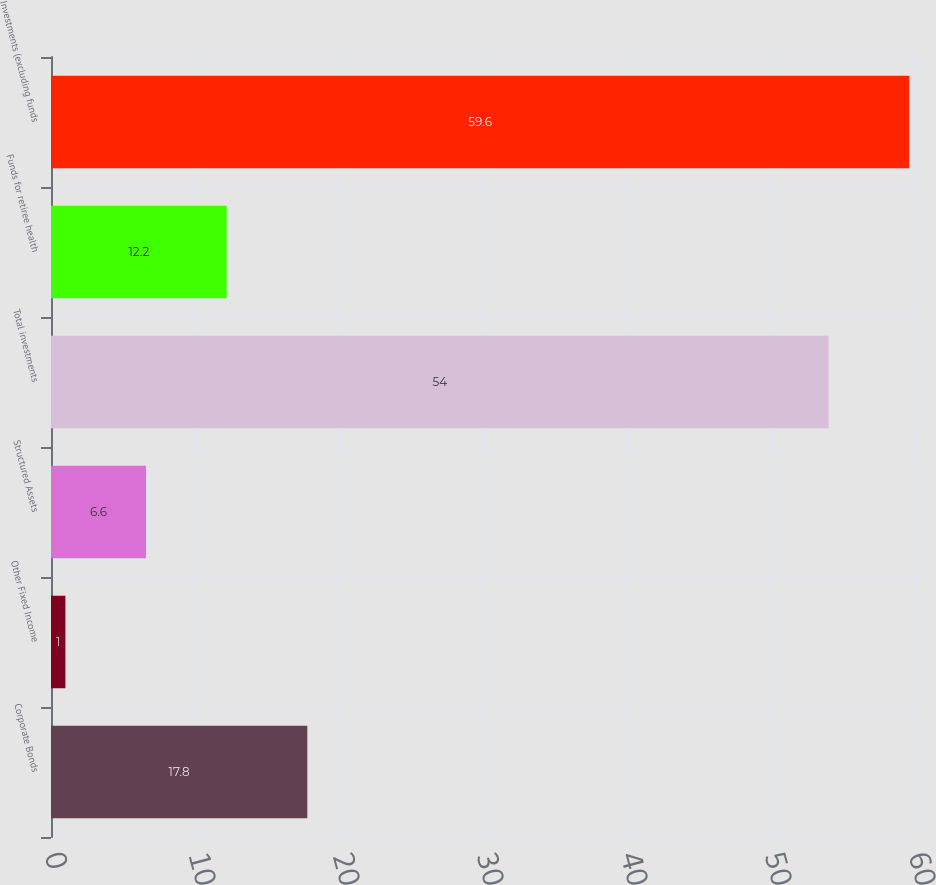Convert chart to OTSL. <chart><loc_0><loc_0><loc_500><loc_500><bar_chart><fcel>Corporate Bonds<fcel>Other Fixed Income<fcel>Structured Assets<fcel>Total investments<fcel>Funds for retiree health<fcel>Investments (excluding funds<nl><fcel>17.8<fcel>1<fcel>6.6<fcel>54<fcel>12.2<fcel>59.6<nl></chart> 